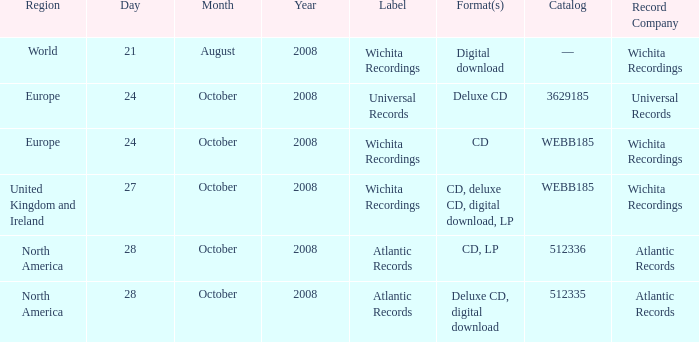Can you parse all the data within this table? {'header': ['Region', 'Day', 'Month', 'Year', 'Label', 'Format(s)', 'Catalog', 'Record Company'], 'rows': [['World', '21', 'August', '2008', 'Wichita Recordings', 'Digital download', '—', 'Wichita Recordings'], ['Europe', '24', 'October', '2008', 'Universal Records', 'Deluxe CD', '3629185', 'Universal Records'], ['Europe', '24', 'October', '2008', 'Wichita Recordings', 'CD', 'WEBB185', 'Wichita Recordings'], ['United Kingdom and Ireland', '27', 'October', '2008', 'Wichita Recordings', 'CD, deluxe CD, digital download, LP', 'WEBB185', 'Wichita Recordings'], ['North America', '28', 'October', '2008', 'Atlantic Records', 'CD, LP', '512336', 'Atlantic Records'], ['North America', '28', 'October', '2008', 'Atlantic Records', 'Deluxe CD, digital download', '512335', 'Atlantic Records']]} Which region is associated with the catalog value of 512335? North America. 